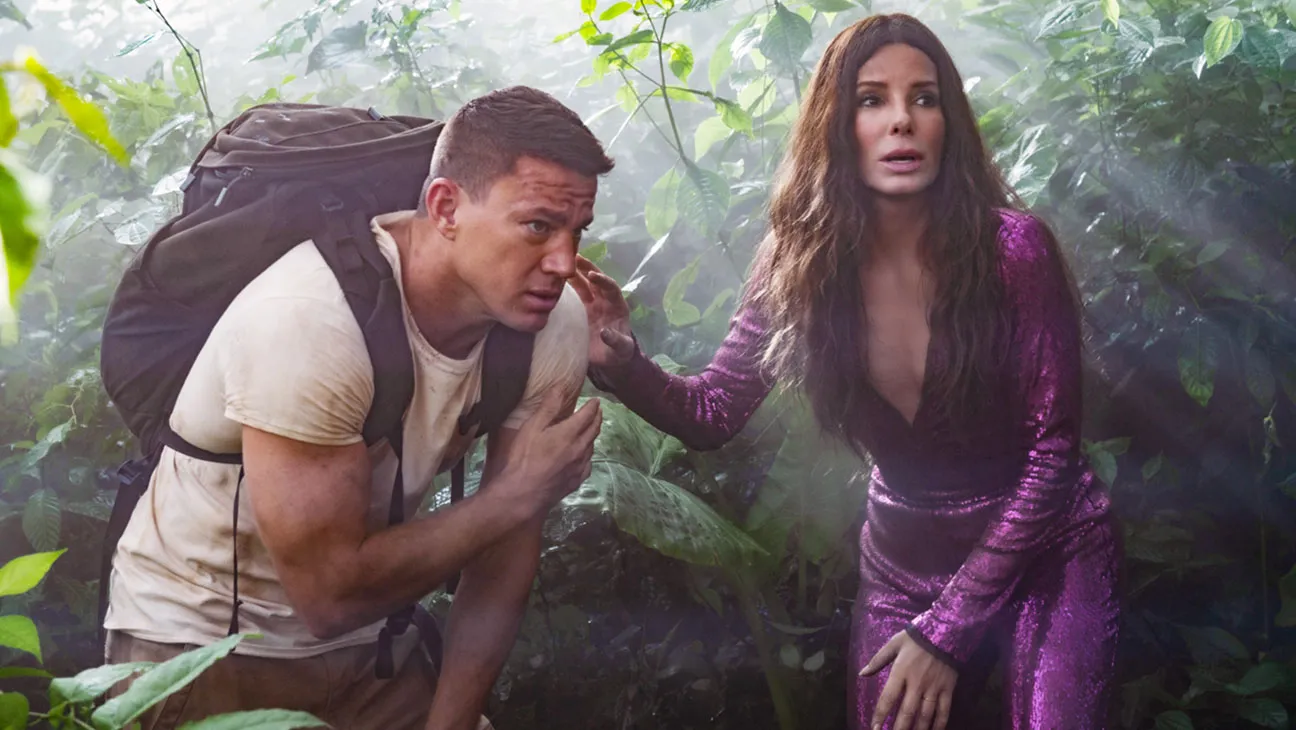Can you describe the significance of the costume choices for the characters in this image? Certainly, the contrasting costumes of the characters help emphasize their roles and personalities. Sandra Bullock's vibrant purple dress suggests a glamorous yet impractical outfit for a jungle, perhaps highlighting her character's unexpected involvement in rugged conditions. Channing Tatum's gear is more rugged and practical, equipped for physical challenges, indicating his role might involve more hands-on action and practical skills in the wild environment. 